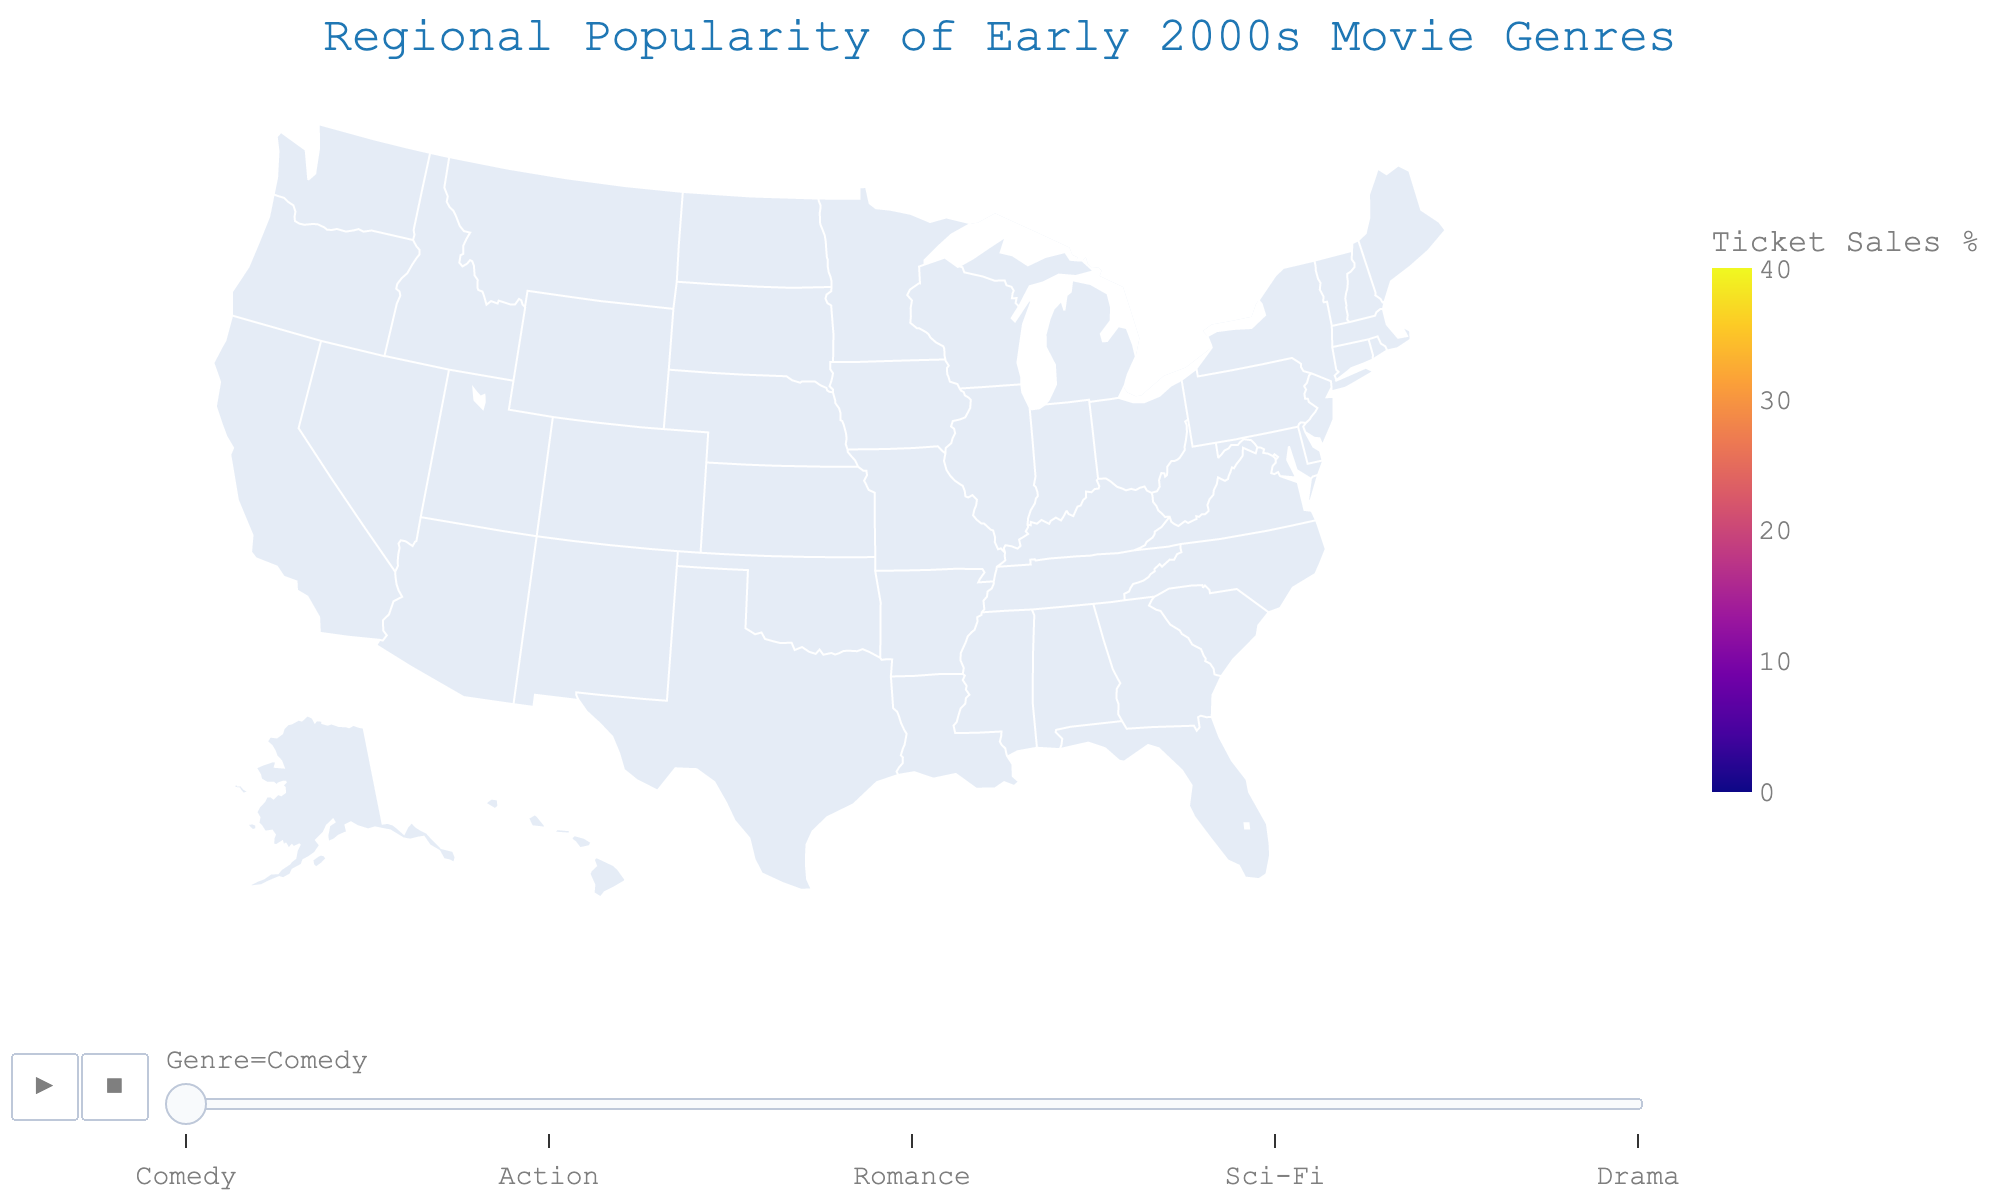what is the title of the plot? The title is usually displayed at the top of the plot and gives a high-level summary of what the plot represents. In this case, it explains the subject of the map visualization.
Answer: Regional Popularity of Early 2000s Movie Genres Which region shows the highest ticket sales for Comedy? To determine this, look at the map and identify which region has the highest "Popularity" value for the Comedy genre during its respective time frame in the animation.
Answer: Texas What is the average ticket sales percentage for Romance across all regions? Sum the ticket sales percentages for Romance in all regions and divide by the number of regions. The values are 18, 20, 15, 16, 17, 19, 14, 22, 13, and 21. Adding these gives 175, and dividing by 10 regions gives an average of 17.5.
Answer: 17.5 Which genre is most popular in the West region? For the West region, compare the ticket sales percentages across all genres: Comedy (28), Action (32), Romance (16), Sci-Fi (18), Drama (6). The highest value tells the most popular genre.
Answer: Action How does the popularity of Sci-Fi in California compare to its popularity in the Midwest? Identify and compare the Sci-Fi values for California and the Midwest. California has a value of 15, whereas the Midwest has a value of 12.
Answer: Higher Which regions have Drama as their least popular genre? Identify which regions have the lowest value for Drama compared to other genres within the same region. From the data, the regions are Northeast, West, California, and Florida, where Drama has the lowest value.
Answer: Northeast, West, California, Florida Which region shows the least interest in Action movies? To find this, look for the region with the lowest "Popularity" value for the Action genre from the data provided. The Northeast region has the lowest value for Action with 28.
Answer: Northeast How does the popularity of Comedy in the South compare to the Northeast? Compare the ticket sales percentages of Comedy in both regions. The South has a value of 35, while the Northeast has a value of 32.
Answer: Higher What is the sum of ticket sales percentages for Sci-Fi and Drama combined in New England? Add the values for Sci-Fi (17) and Drama (9) from the New England region: 17 + 9 = 26.
Answer: 26 During which genre's frame does Texas show the highest popularity? By cycling through each genre frame, you can see that Texas displays the highest ticket sales percentage (36) during the Comedy genre frame.
Answer: Comedy How does ticket sales percentage for Romance in Florida compare to the Southwest? Compare the Romance values in Florida (22) and the Southwest (17).
Answer: Higher 